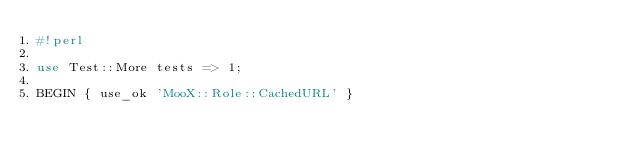<code> <loc_0><loc_0><loc_500><loc_500><_Perl_>#!perl

use Test::More tests => 1;

BEGIN { use_ok 'MooX::Role::CachedURL' }
</code> 